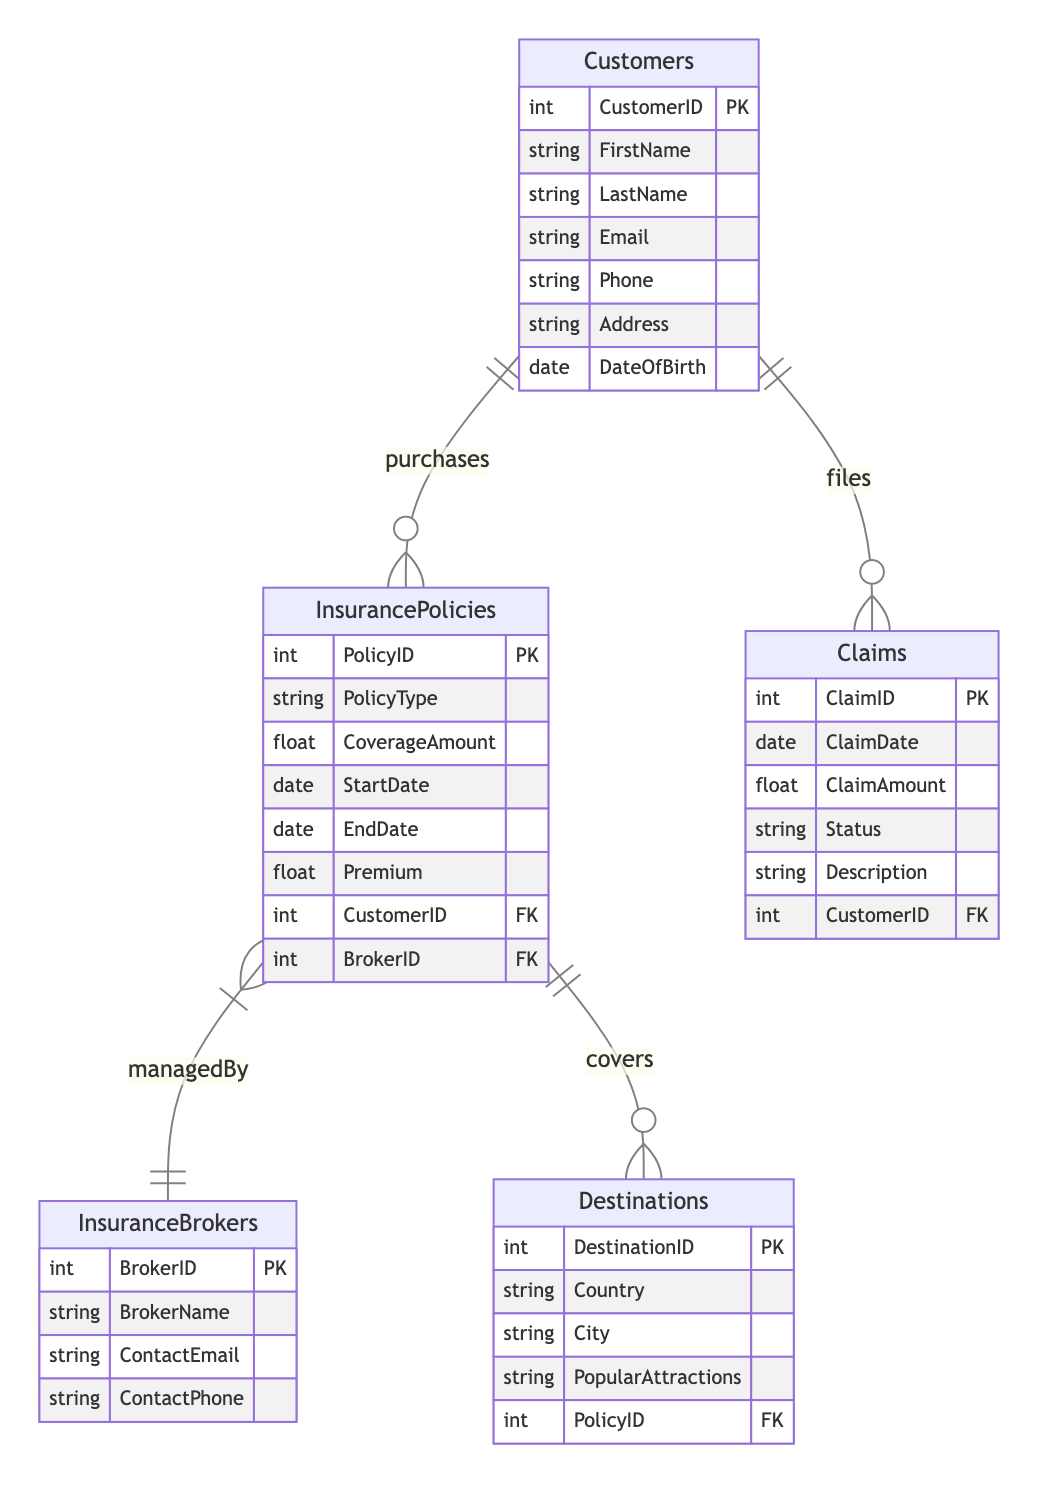What is the primary key of the Customers entity? The primary key is indicated by 'PK' next to the attribute name in the Customers entity section of the diagram, which shows that "CustomerID" is the primary key.
Answer: CustomerID How many attributes does the InsurancePolicies entity have? By counting the listed attributes in the InsurancePolicies section, there are six attributes: PolicyID, PolicyType, CoverageAmount, StartDate, EndDate, and Premium.
Answer: 6 What relationship exists between Customers and Claims? The relationship line from Customers to Claims is labeled "files", indicating that Customers file Claims.
Answer: files Which entity does the InsurancePolicies entity manage by? The relationship from InsurancePolicies to InsuranceBrokers is marked with "managedBy", indicating that each InsurancePolicy is managed by an InsuranceBroker.
Answer: InsuranceBrokers What foreign key is present in the Claims entity? The diagram shows the Claims entity has a foreign key "CustomerID", which links it to the Customers entity.
Answer: CustomerID Which entity is connected to Destinations through the "covers" relationship? The diagram shows a line connecting InsurancePolicies to Destinations, labeled "covers", indicating that InsurancePolicies provide coverage for Destinations.
Answer: InsurancePolicies How many entities are in this Entity Relationship Diagram? By counting the listed entities section in the diagram, there are five entities: Customers, InsurancePolicies, InsuranceBrokers, Claims, and Destinations.
Answer: 5 In which relationship is the foreign key BrokerID present? The foreign key BrokerID is found in the InsurancePolicies entity relationship with InsuranceBrokers, labeled "managedBy", indicating the link between them.
Answer: managedBy What type of relationship is shown between Customers and InsurancePolicies? The line connecting Customers to InsurancePolicies is labeled "purchases", indicating that Customers purchase InsurancePolicies.
Answer: purchases 